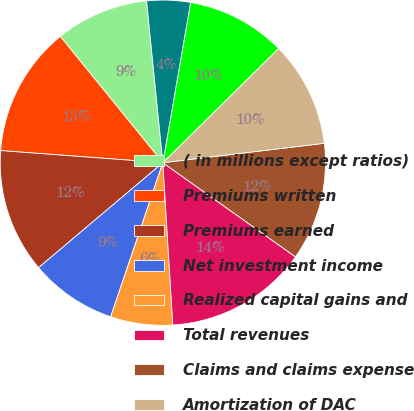Convert chart to OTSL. <chart><loc_0><loc_0><loc_500><loc_500><pie_chart><fcel>( in millions except ratios)<fcel>Premiums written<fcel>Premiums earned<fcel>Net investment income<fcel>Realized capital gains and<fcel>Total revenues<fcel>Claims and claims expense<fcel>Amortization of DAC<fcel>Operating costs and expenses<fcel>Restructuring and related<nl><fcel>9.26%<fcel>12.96%<fcel>12.35%<fcel>8.64%<fcel>6.17%<fcel>14.2%<fcel>11.73%<fcel>10.49%<fcel>9.88%<fcel>4.32%<nl></chart> 